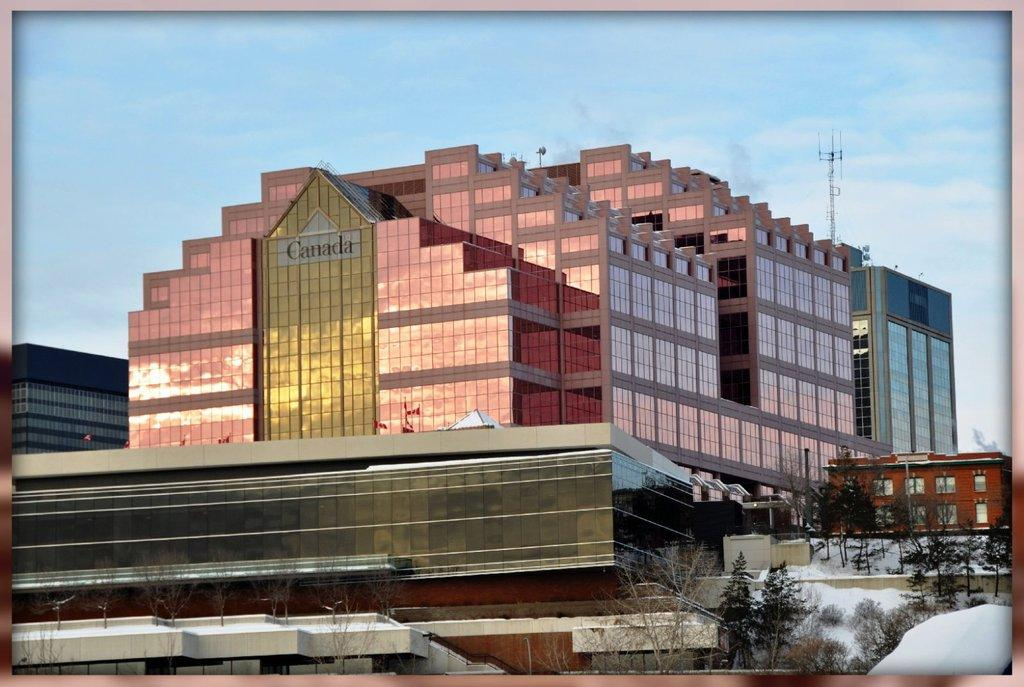What type of structures are present in the image? There are buildings in the image. What is covering the ground in the image? There is snow at the bottom of the image. What type of vegetation can be seen in the image? There are trees in the image. What can be seen in the background of the image? The sky is visible in the background of the image, and there is a tower in the background as well. Where is the calculator located in the image? There is no calculator present in the image. What type of jam is being spread on the trees in the image? There is no jam or spreading activity depicted in the image; it features buildings, snow, trees, and a tower in the background. 